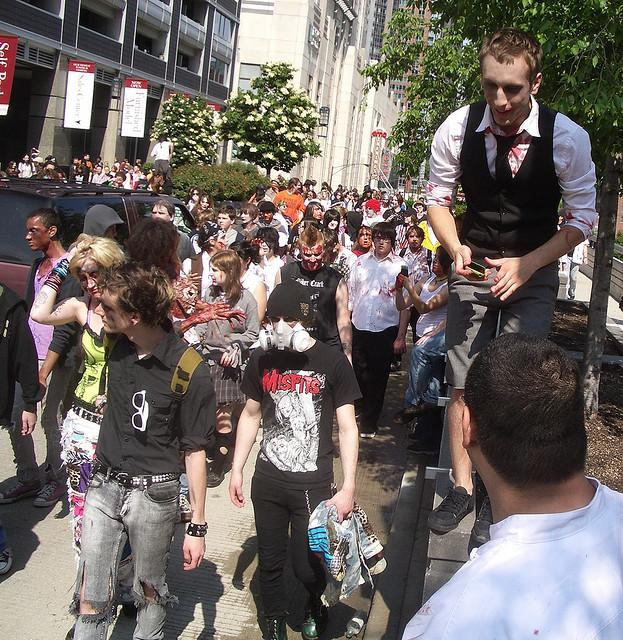The band on the shirt of the man wearing a mask belongs to what genre of music? punk 